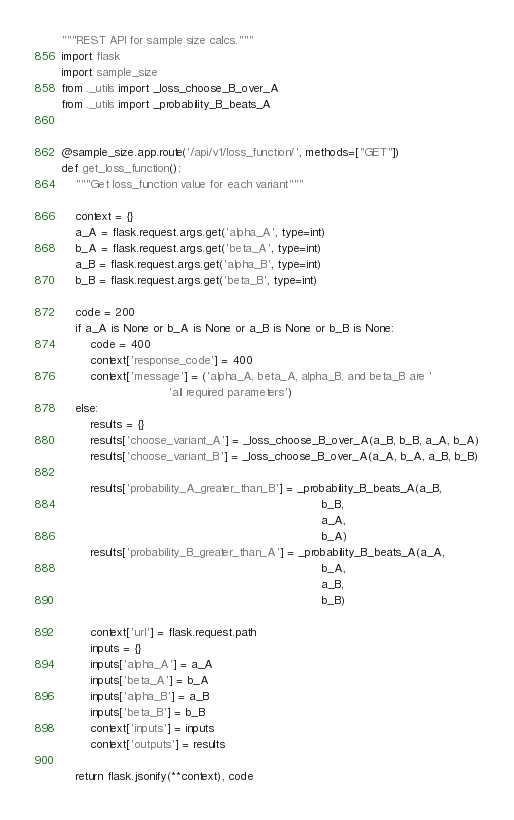Convert code to text. <code><loc_0><loc_0><loc_500><loc_500><_Python_>"""REST API for sample size calcs."""
import flask
import sample_size
from ._utils import _loss_choose_B_over_A
from ._utils import _probability_B_beats_A


@sample_size.app.route('/api/v1/loss_function/', methods=["GET"])
def get_loss_function():
    """Get loss_function value for each variant"""

    context = {}
    a_A = flask.request.args.get('alpha_A', type=int)
    b_A = flask.request.args.get('beta_A', type=int)
    a_B = flask.request.args.get('alpha_B', type=int)
    b_B = flask.request.args.get('beta_B', type=int)

    code = 200
    if a_A is None or b_A is None or a_B is None or b_B is None:
        code = 400
        context['response_code'] = 400
        context['message'] = ('alpha_A, beta_A, alpha_B, and beta_B are '
                              'all required parameters')
    else:
        results = {}
        results['choose_variant_A'] = _loss_choose_B_over_A(a_B, b_B, a_A, b_A)
        results['choose_variant_B'] = _loss_choose_B_over_A(a_A, b_A, a_B, b_B)

        results['probability_A_greater_than_B'] = _probability_B_beats_A(a_B,
                                                                         b_B,
                                                                         a_A,
                                                                         b_A)
        results['probability_B_greater_than_A'] = _probability_B_beats_A(a_A,
                                                                         b_A,
                                                                         a_B,
                                                                         b_B)

        context['url'] = flask.request.path
        inputs = {}
        inputs['alpha_A'] = a_A
        inputs['beta_A'] = b_A
        inputs['alpha_B'] = a_B
        inputs['beta_B'] = b_B
        context['inputs'] = inputs
        context['outputs'] = results

    return flask.jsonify(**context), code
</code> 